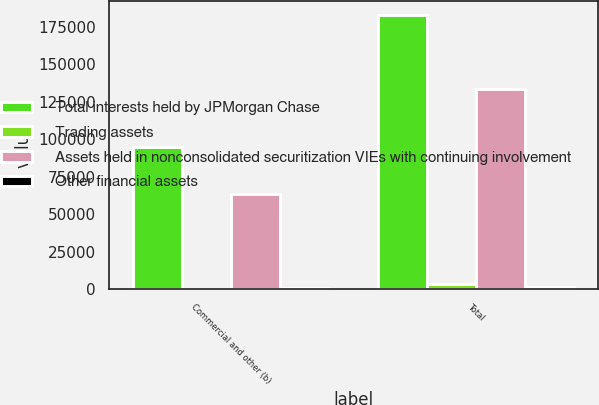<chart> <loc_0><loc_0><loc_500><loc_500><stacked_bar_chart><ecel><fcel>Commercial and other (b)<fcel>Total<nl><fcel>Total interests held by JPMorgan Chase<fcel>94905<fcel>182763<nl><fcel>Trading assets<fcel>63<fcel>3685<nl><fcel>Assets held in nonconsolidated securitization VIEs with continuing involvement<fcel>63411<fcel>133303<nl><fcel>Other financial assets<fcel>745<fcel>1248<nl></chart> 